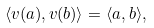Convert formula to latex. <formula><loc_0><loc_0><loc_500><loc_500>\langle v ( a ) , v ( b ) \rangle = \langle a , b \rangle ,</formula> 